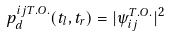Convert formula to latex. <formula><loc_0><loc_0><loc_500><loc_500>p ^ { i j T . O . } _ { d } ( t _ { l } , t _ { r } ) = | \psi ^ { T . O . } _ { i j } | ^ { 2 }</formula> 